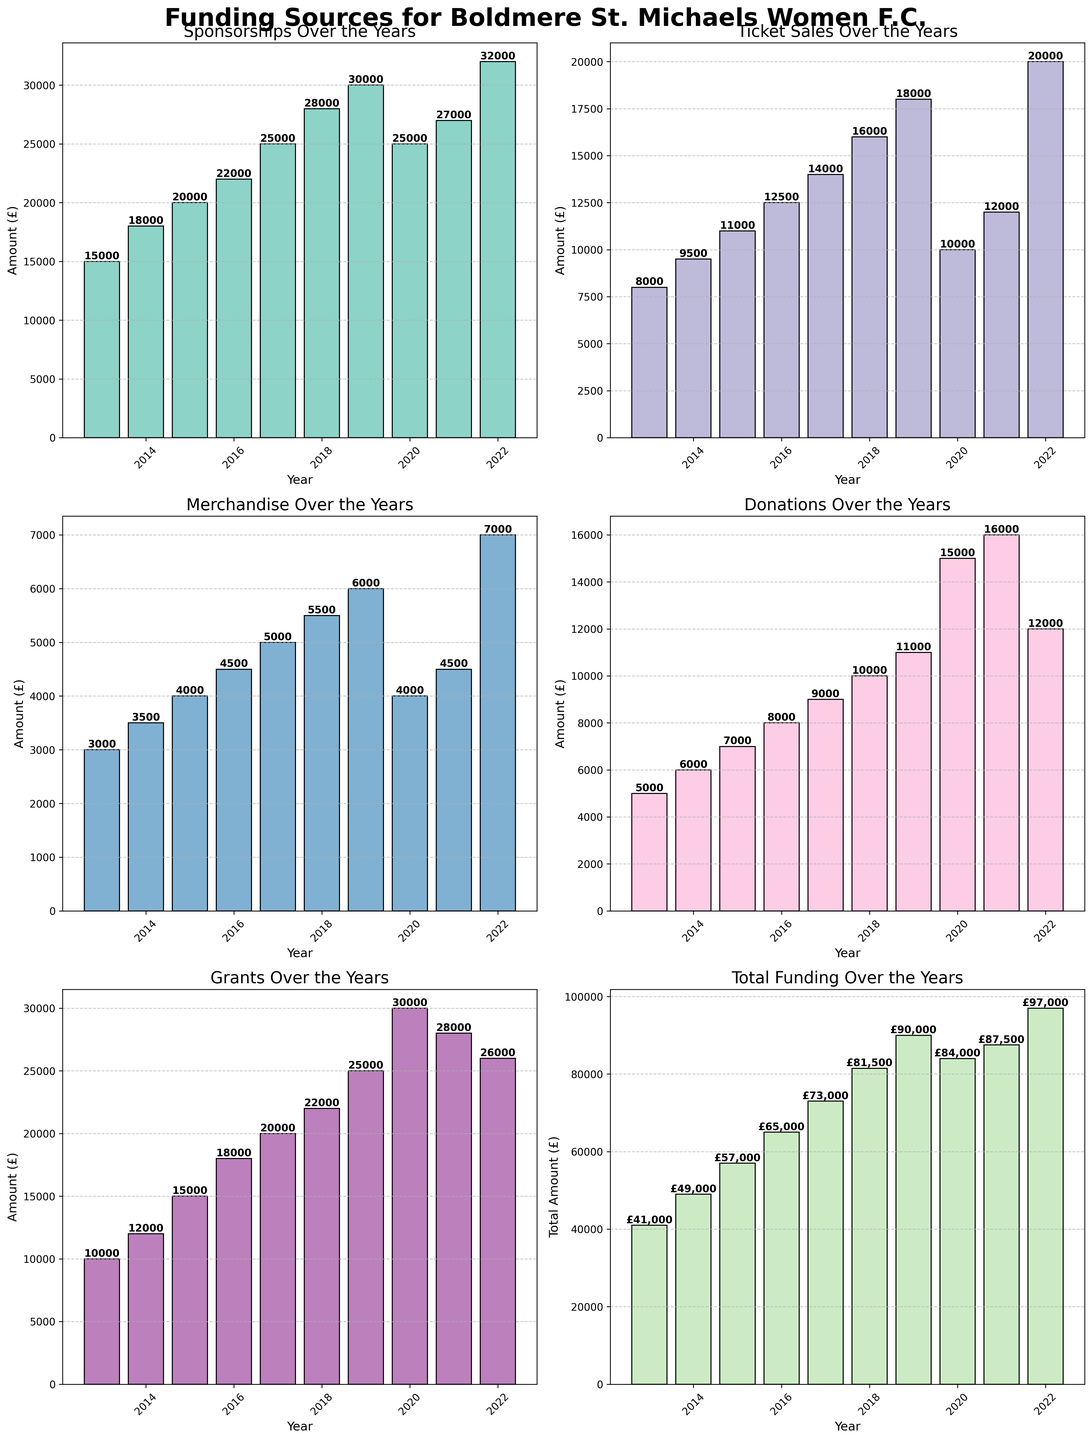What is the total funding for the year 2015? The total funding for a year is the sum of all funding sources. From the 2015 bar charts, sponsorships are £20000, ticket sales are £11000, merchandise is £4000, donations are £7000, and grants are £15000. Summing these, 20000 + 11000 + 4000 + 7000 + 15000 gives £57000.
Answer: £57000 Which funding source saw the highest amount in 2020? To determine this, identify the highest bar in the year 2020 across all categories. Sponsorships are £25000, ticket sales are £10000, merchandise is £4000, donations are £15000, and grants are £30000. The highest value is £30000 from grants.
Answer: Grants How did the funding from donations change from 2021 to 2022? Compare the height of the donation bars for 2021 and 2022. In 2021, donations were £16000, and in 2022, they were £12000. The change is a decrease from £16000 to £12000, which is a decrease of £4000.
Answer: Decreased by £4000 In which years did sponsorships surpass £25000? Review the bars for sponsorships and identify the years where the bar height exceeds £25000. From the chart, in 2018 (£28000), 2019 (£30000), 2021 (£27000), and 2022 (£32000), sponsorships surpassed £25000.
Answer: 2018, 2019, 2021, 2022 Which year experienced the largest total funding? Compare the total funding bars across all years to determine the highest one. It can be seen that 2020 has the largest total funding with all sources summing up to £84000.
Answer: 2020 Which funding category displayed the most consistent growth over the years? Assess the trend in the heights of the bars across all the years for each category. Sponsorships show a consistent upward trend from 2013 to 2022, except for 2020 where there's a drop. Other categories, such as donations and grants, display more variability.
Answer: Sponsorships Calculate the average ticket sales over the years 2013 to 2022. To find the average, add up the ticket sales for all years and divide by the number of years. (8000 + 9500 + 11000 + 12500 + 14000 + 16000 + 18000 + 10000 + 12000 + 20000) totals to 1,35000. Dividing by 10 years gives an average of £13500.
Answer: £13500 By how much did the merchandise funding increase from 2013 to 2022? Determine the difference between the funding amounts for merchandise in 2013 and 2022. In 2013, it was £3000, and in 2022, it was £7000. The increase is 7000 - 3000, which is £4000.
Answer: £4000 In which year did ticket sales exceed merchandise sales by the largest amount? Identify the year with the largest difference by looking at the heights of the ticket sales and merchandise bars. In 2022, ticket sales were £20000 and merchandise sales were £7000. The difference is 20000 - 7000, which is £13000. Thus, 2022 had the largest difference.
Answer: 2022 